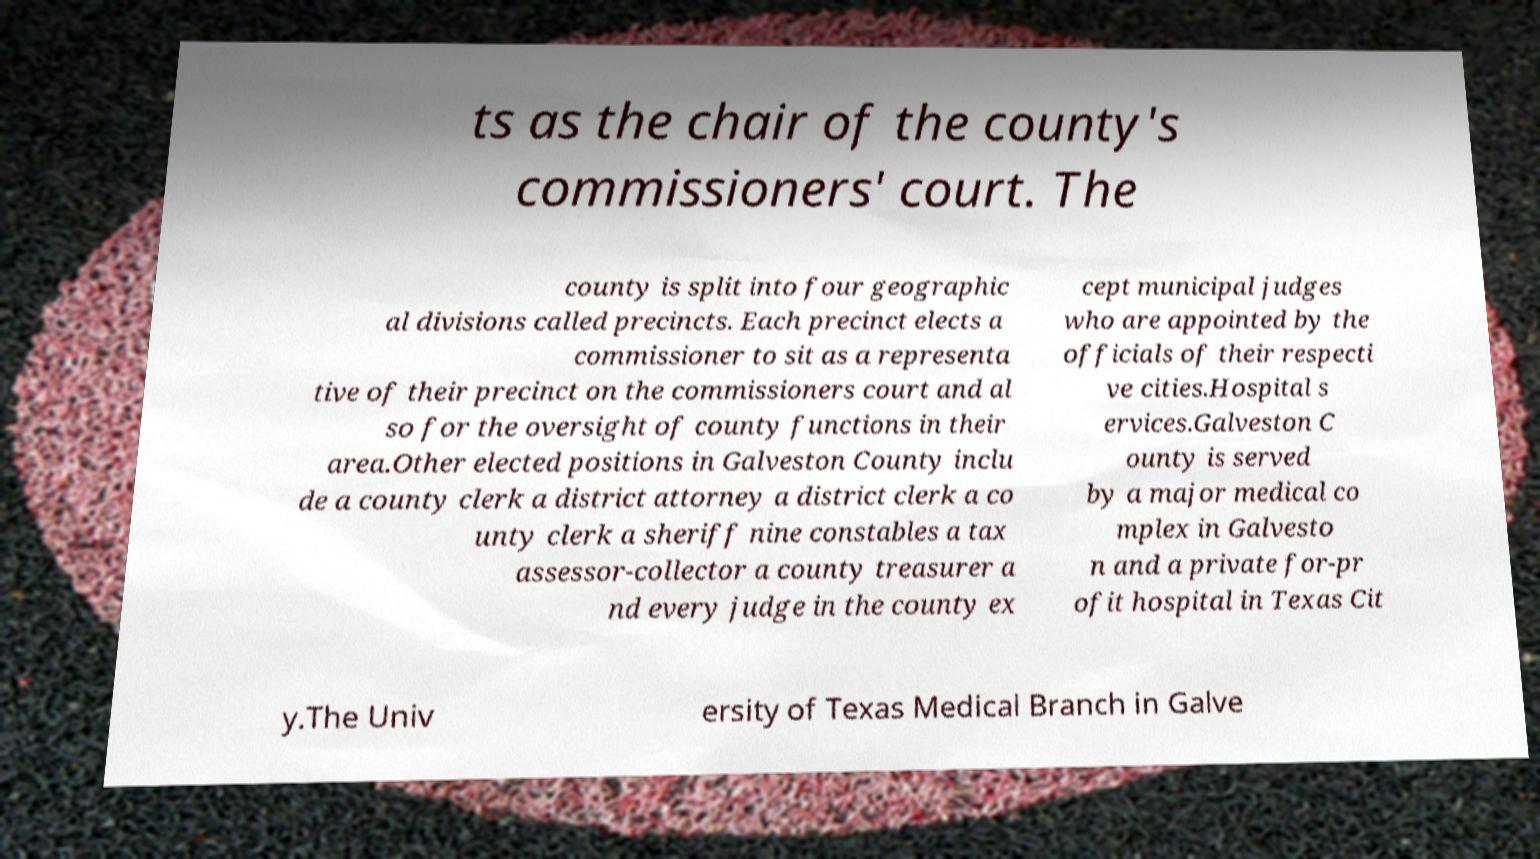Could you extract and type out the text from this image? ts as the chair of the county's commissioners' court. The county is split into four geographic al divisions called precincts. Each precinct elects a commissioner to sit as a representa tive of their precinct on the commissioners court and al so for the oversight of county functions in their area.Other elected positions in Galveston County inclu de a county clerk a district attorney a district clerk a co unty clerk a sheriff nine constables a tax assessor-collector a county treasurer a nd every judge in the county ex cept municipal judges who are appointed by the officials of their respecti ve cities.Hospital s ervices.Galveston C ounty is served by a major medical co mplex in Galvesto n and a private for-pr ofit hospital in Texas Cit y.The Univ ersity of Texas Medical Branch in Galve 